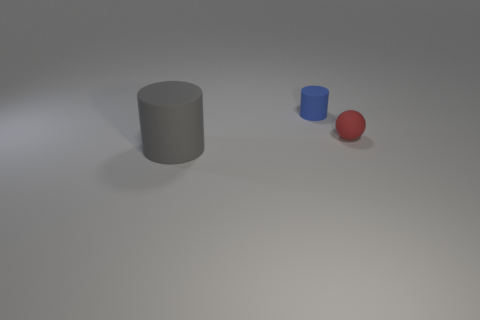Can you tell me the colors of the objects starting from the left? From the left, the first object is a large gray cylinder, the second object is a smaller blue cylinder, and the third object is a red sphere. 